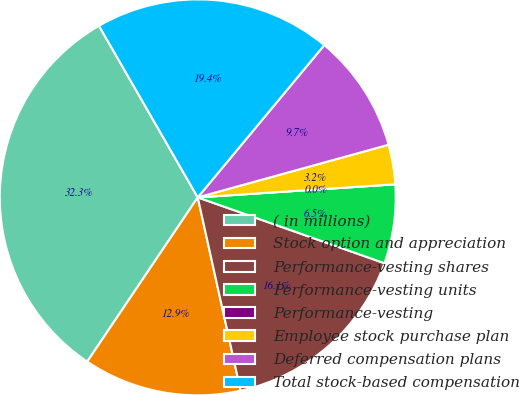<chart> <loc_0><loc_0><loc_500><loc_500><pie_chart><fcel>( in millions)<fcel>Stock option and appreciation<fcel>Performance-vesting shares<fcel>Performance-vesting units<fcel>Performance-vesting<fcel>Employee stock purchase plan<fcel>Deferred compensation plans<fcel>Total stock-based compensation<nl><fcel>32.26%<fcel>12.9%<fcel>16.13%<fcel>6.45%<fcel>0.0%<fcel>3.23%<fcel>9.68%<fcel>19.35%<nl></chart> 